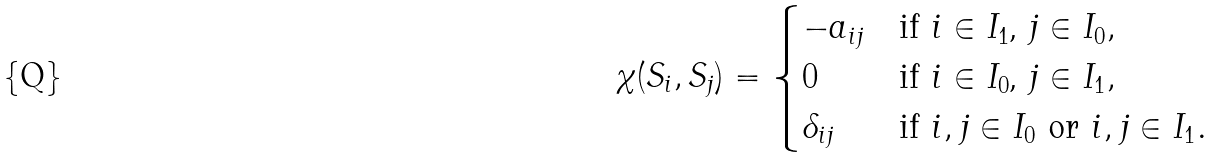<formula> <loc_0><loc_0><loc_500><loc_500>\chi ( S _ { i } , S _ { j } ) = \begin{cases} - a _ { i j } & \text {if $i\in I_{1}$, $j\in I_{0}$} , \\ 0 & \text {if $i\in I_{0}$, $j\in I_{1}$} , \\ \delta _ { i j } & \text {if $i,j\in I_{0}$ or $i,j\in I_{1}$} . \end{cases}</formula> 